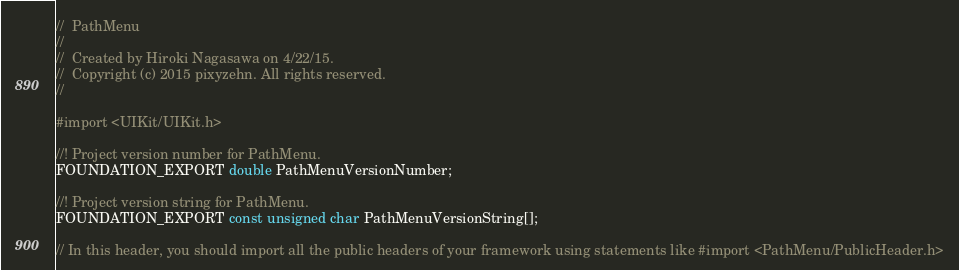<code> <loc_0><loc_0><loc_500><loc_500><_C_>//  PathMenu
//
//  Created by Hiroki Nagasawa on 4/22/15.
//  Copyright (c) 2015 pixyzehn. All rights reserved.
//

#import <UIKit/UIKit.h>

//! Project version number for PathMenu.
FOUNDATION_EXPORT double PathMenuVersionNumber;

//! Project version string for PathMenu.
FOUNDATION_EXPORT const unsigned char PathMenuVersionString[];

// In this header, you should import all the public headers of your framework using statements like #import <PathMenu/PublicHeader.h>


</code> 